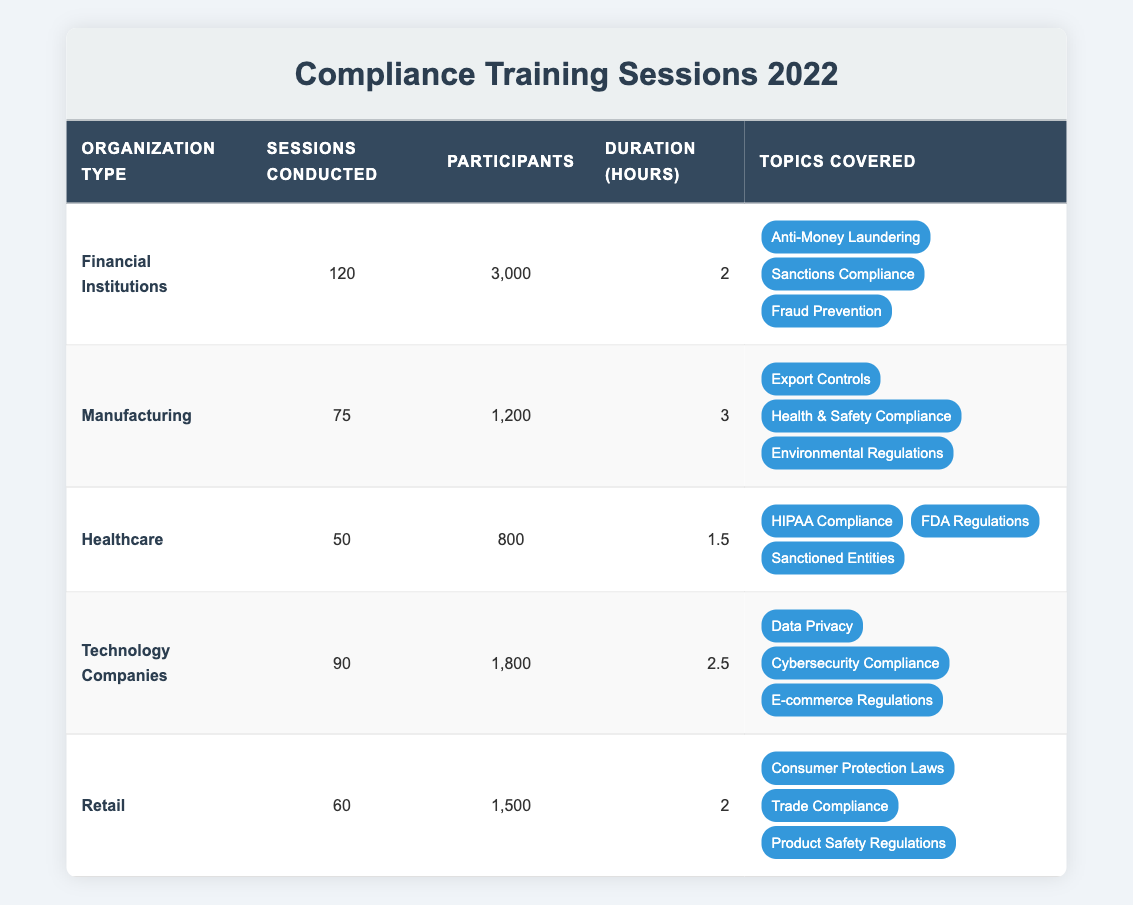What organization type conducted the most compliance training sessions in 2022? Referring to the "Sessions Conducted" column, the row for "Financial Institutions" shows the highest number at 120 sessions.
Answer: Financial Institutions How many total participants attended the compliance training sessions across all organization types? Adding the participants from all rows: 3000 + 1200 + 800 + 1800 + 1500 = 7200 in total.
Answer: 7200 Which organization type had the longest average duration of training sessions? Comparing duration hours: Financial Institutions (2), Manufacturing (3), Healthcare (1.5), Technology Companies (2.5), and Retail (2). Manufacturing had the longest duration at 3 hours.
Answer: Manufacturing Is it true that Healthcare conducted more training sessions than Retail? Checking the "Sessions Conducted" column: Healthcare (50) conducted fewer sessions than Retail (60). Thus, the statement is false.
Answer: No What is the average number of sessions conducted by all the organization types? There are five types of organizations. The total sessions conducted are 120 + 75 + 50 + 90 + 60 = 395. Dividing by 5 gives an average of 79.
Answer: 79 Which training topics were covered by the Financial Institutions? Looking at the topics covered for Financial Institutions, they include Anti-Money Laundering, Sanctions Compliance, and Fraud Prevention.
Answer: Anti-Money Laundering, Sanctions Compliance, Fraud Prevention If we combine the participants from Technology Companies and Retail, how many participants attended their sessions in total? Adding the participants from Technology Companies (1800) and Retail (1500) gives 1800 + 1500 = 3300 participants in total.
Answer: 3300 What percentage of the total sessions was conducted by the Healthcare organization type? The total sessions conducted are 395. The number of sessions conducted by Healthcare is 50. Therefore, (50 / 395) * 100 = approximately 12.66%.
Answer: Approximately 12.66% Which organization type covered "Sanctions Compliance" in their training? From the topics covered, "Sanctions Compliance" is listed under the Financial Institutions and Healthcare organizations.
Answer: Financial Institutions, Healthcare 